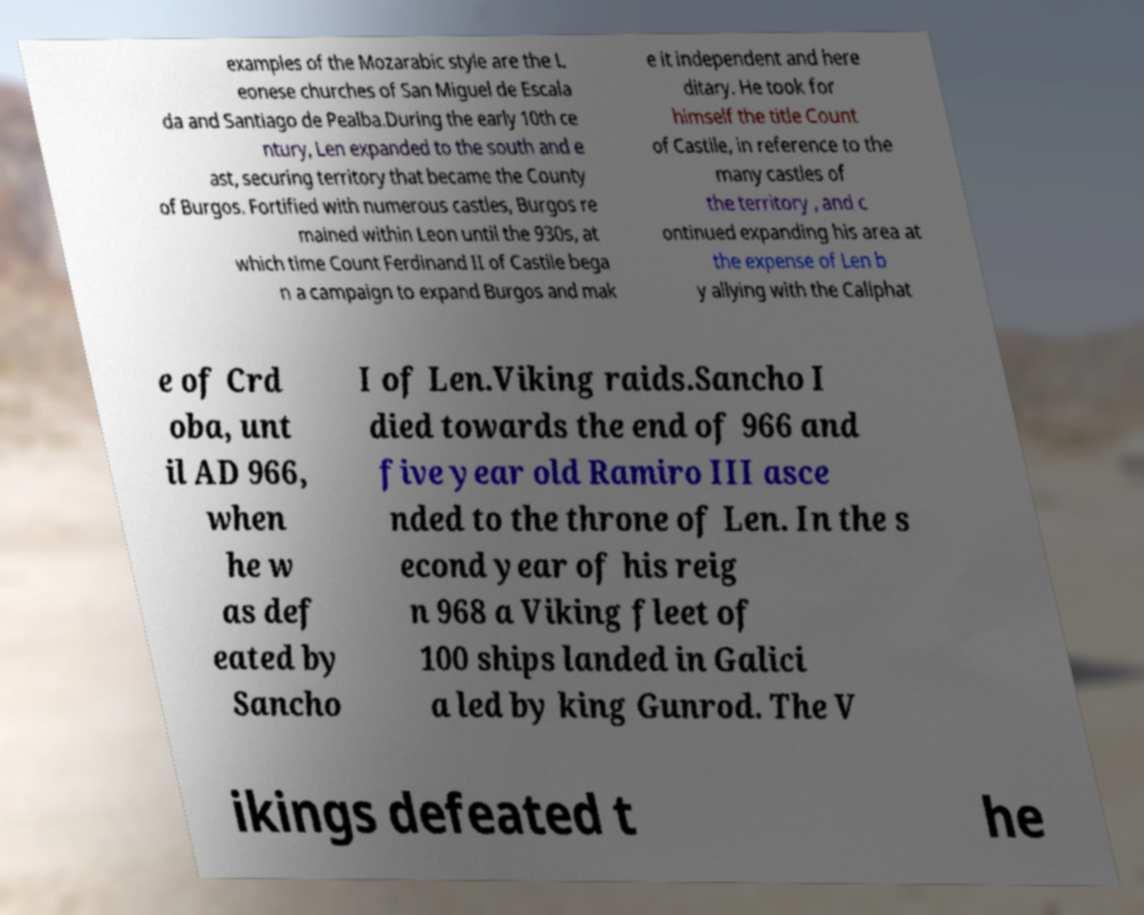Please identify and transcribe the text found in this image. examples of the Mozarabic style are the L eonese churches of San Miguel de Escala da and Santiago de Pealba.During the early 10th ce ntury, Len expanded to the south and e ast, securing territory that became the County of Burgos. Fortified with numerous castles, Burgos re mained within Leon until the 930s, at which time Count Ferdinand II of Castile bega n a campaign to expand Burgos and mak e it independent and here ditary. He took for himself the title Count of Castile, in reference to the many castles of the territory , and c ontinued expanding his area at the expense of Len b y allying with the Caliphat e of Crd oba, unt il AD 966, when he w as def eated by Sancho I of Len.Viking raids.Sancho I died towards the end of 966 and five year old Ramiro III asce nded to the throne of Len. In the s econd year of his reig n 968 a Viking fleet of 100 ships landed in Galici a led by king Gunrod. The V ikings defeated t he 